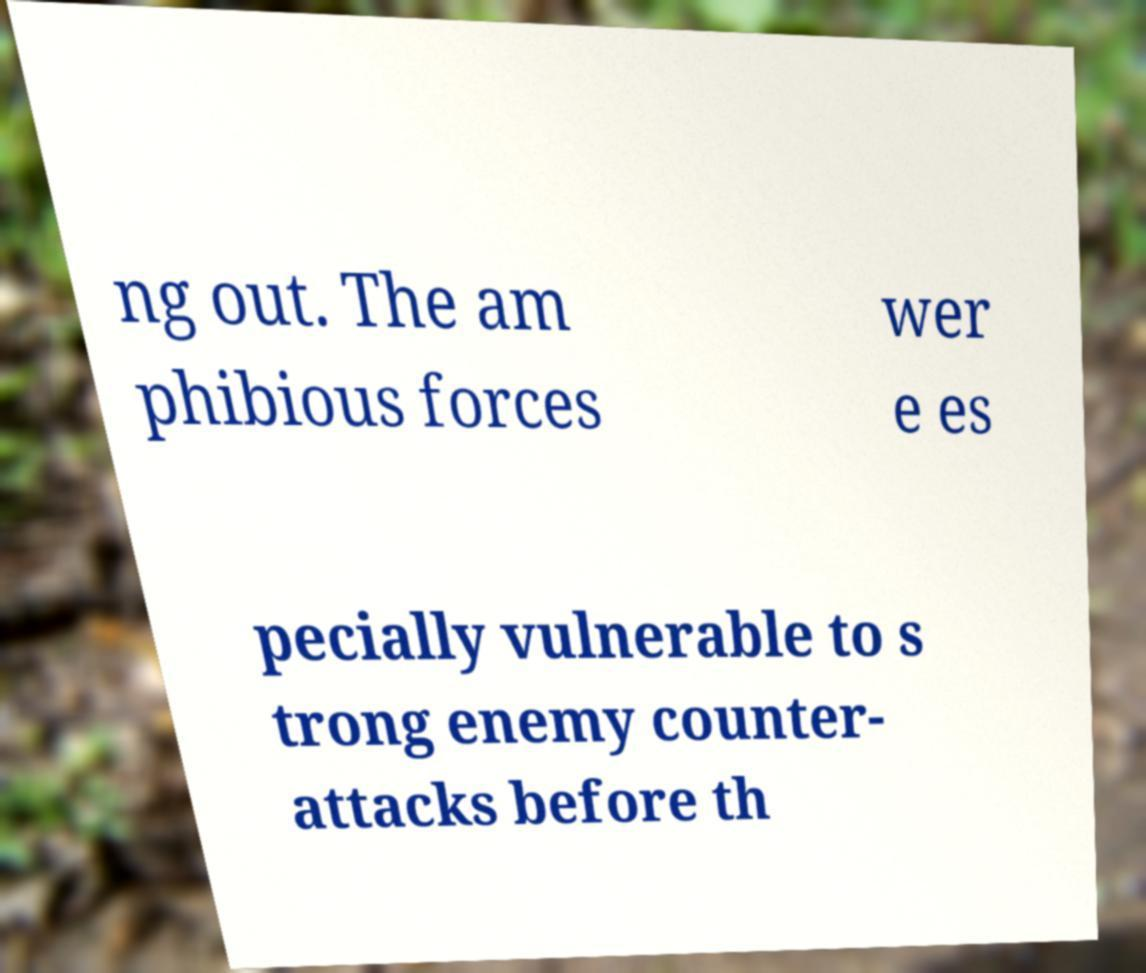Please identify and transcribe the text found in this image. ng out. The am phibious forces wer e es pecially vulnerable to s trong enemy counter- attacks before th 